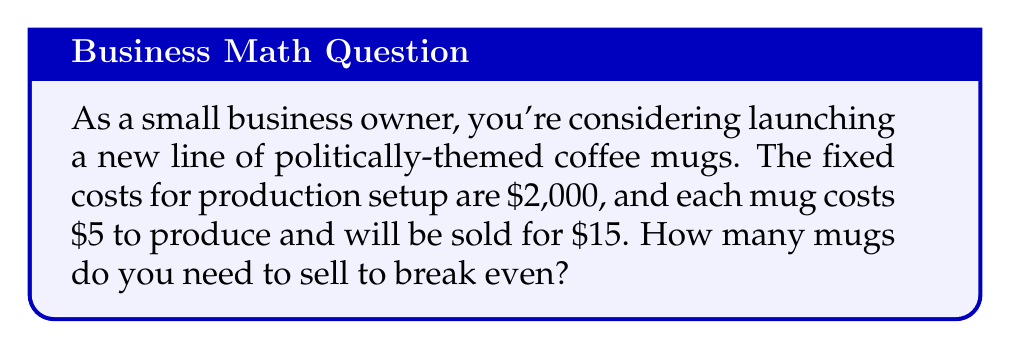Provide a solution to this math problem. To solve this problem, we need to understand the concept of the break-even point. The break-even point is where total revenue equals total costs, resulting in zero profit or loss.

Let's define our variables:
$x$ = number of mugs sold
$F$ = fixed costs
$P$ = selling price per mug
$C$ = cost to produce each mug

We know:
$F = \$2,000$
$P = \$15$
$C = \$5$

The break-even point occurs when:

Total Revenue = Total Costs

Mathematically, this can be expressed as:
$$ Px = F + Cx $$

Substituting our known values:
$$ 15x = 2000 + 5x $$

Now, let's solve for $x$:
$$ 15x - 5x = 2000 $$
$$ 10x = 2000 $$
$$ x = \frac{2000}{10} = 200 $$

Therefore, you need to sell 200 mugs to break even.

To verify:
Revenue at 200 mugs: $200 * \$15 = \$3,000$
Total costs at 200 mugs: $\$2,000 + (200 * \$5) = \$3,000$

Revenue equals total costs, confirming the break-even point.
Answer: 200 mugs 